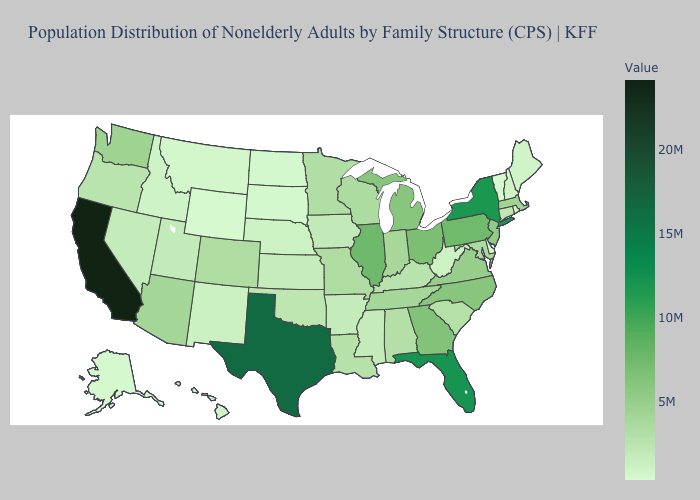Does West Virginia have the highest value in the USA?
Quick response, please. No. Among the states that border West Virginia , which have the highest value?
Be succinct. Pennsylvania. Does New Mexico have the lowest value in the USA?
Keep it brief. No. Is the legend a continuous bar?
Concise answer only. Yes. Which states have the lowest value in the USA?
Short answer required. Wyoming. Does Illinois have the highest value in the MidWest?
Give a very brief answer. Yes. 